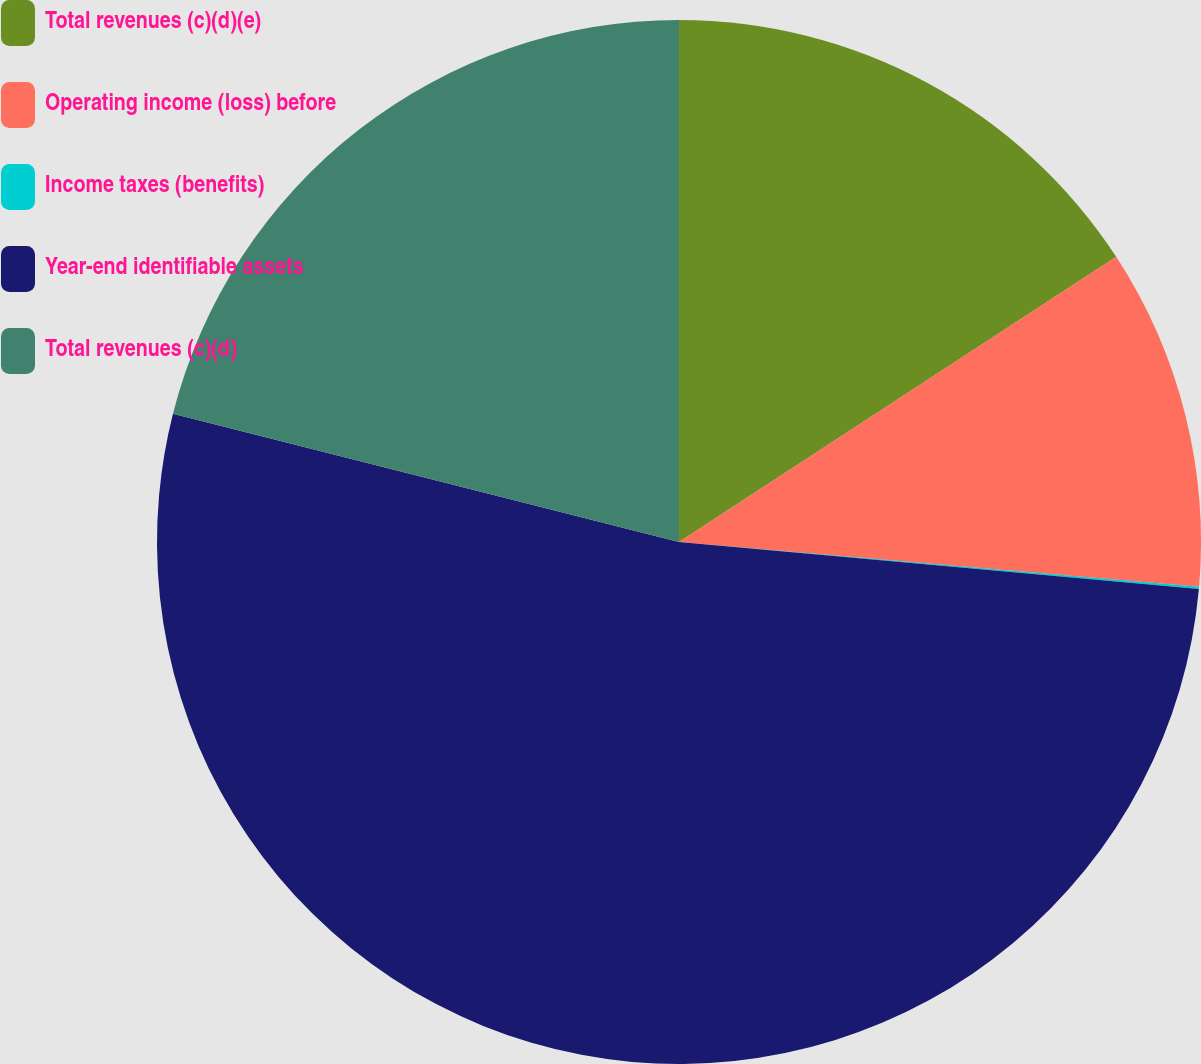<chart> <loc_0><loc_0><loc_500><loc_500><pie_chart><fcel>Total revenues (c)(d)(e)<fcel>Operating income (loss) before<fcel>Income taxes (benefits)<fcel>Year-end identifiable assets<fcel>Total revenues (c)(d)<nl><fcel>15.8%<fcel>10.56%<fcel>0.07%<fcel>52.51%<fcel>21.05%<nl></chart> 